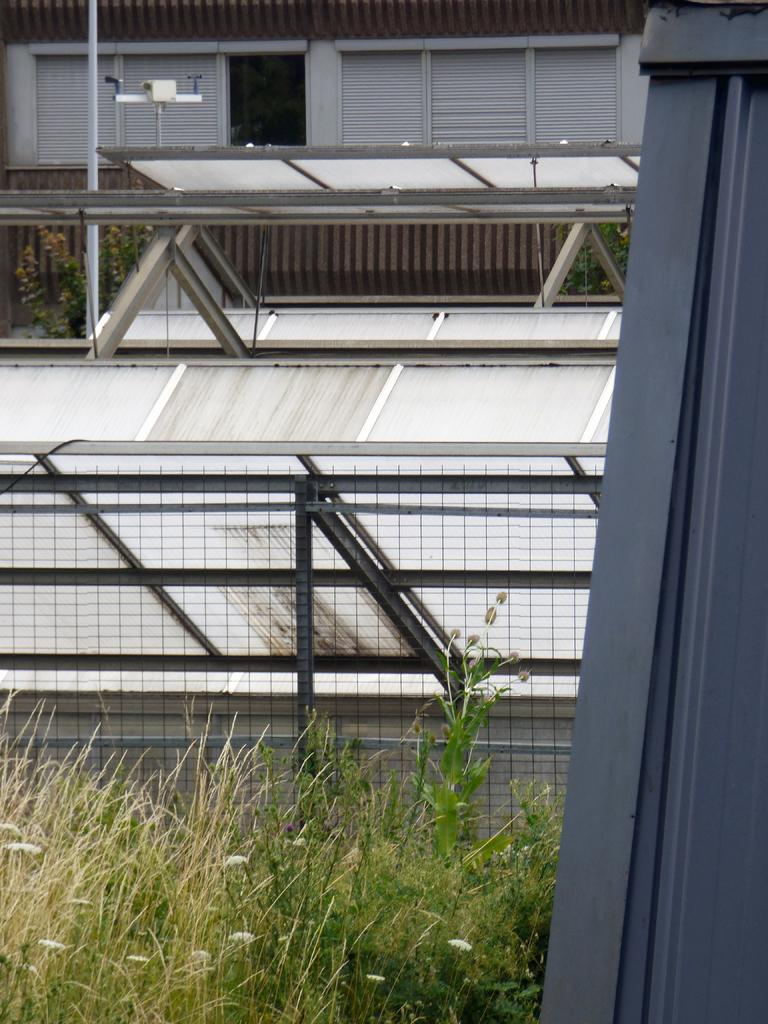What is located in the front of the image? There are plants and an object in the front of the image. Can you describe the object in the front of the image? Unfortunately, the facts provided do not give a description of the object. What can be seen in the background of the image? There is a fence, plants, and parts of buildings in the background of the image. Where are the beds located in the image? There are no beds present in the image. What day is it according to the calendar in the image? There is no calendar present in the image. 